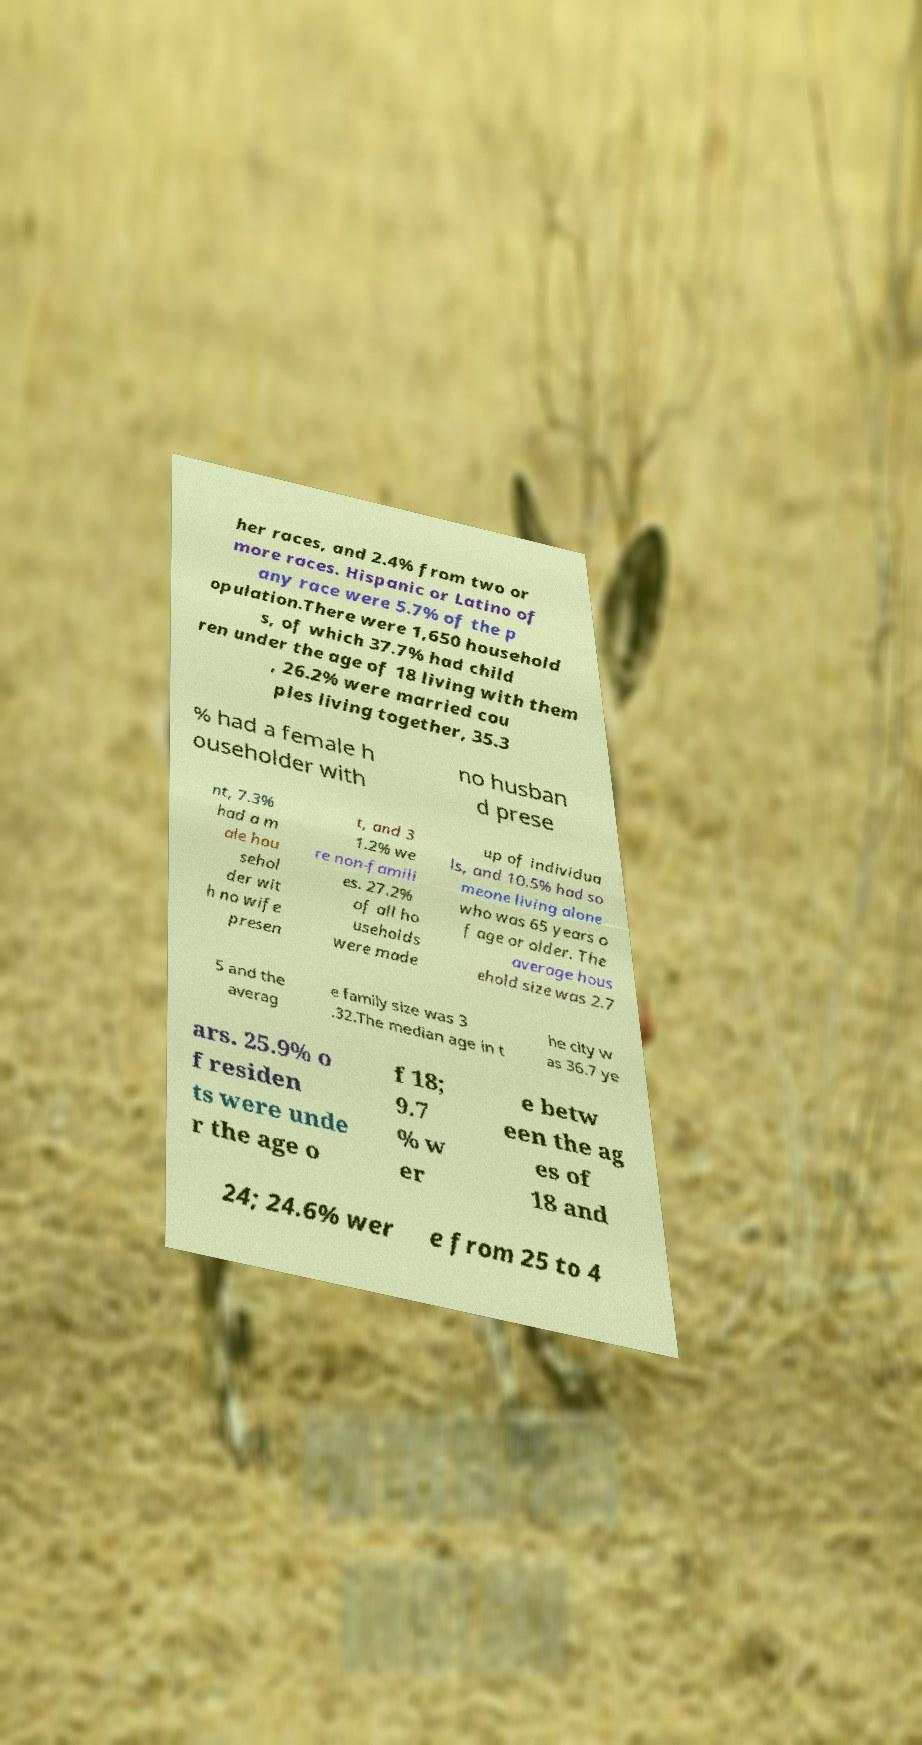Please read and relay the text visible in this image. What does it say? her races, and 2.4% from two or more races. Hispanic or Latino of any race were 5.7% of the p opulation.There were 1,650 household s, of which 37.7% had child ren under the age of 18 living with them , 26.2% were married cou ples living together, 35.3 % had a female h ouseholder with no husban d prese nt, 7.3% had a m ale hou sehol der wit h no wife presen t, and 3 1.2% we re non-famili es. 27.2% of all ho useholds were made up of individua ls, and 10.5% had so meone living alone who was 65 years o f age or older. The average hous ehold size was 2.7 5 and the averag e family size was 3 .32.The median age in t he city w as 36.7 ye ars. 25.9% o f residen ts were unde r the age o f 18; 9.7 % w er e betw een the ag es of 18 and 24; 24.6% wer e from 25 to 4 